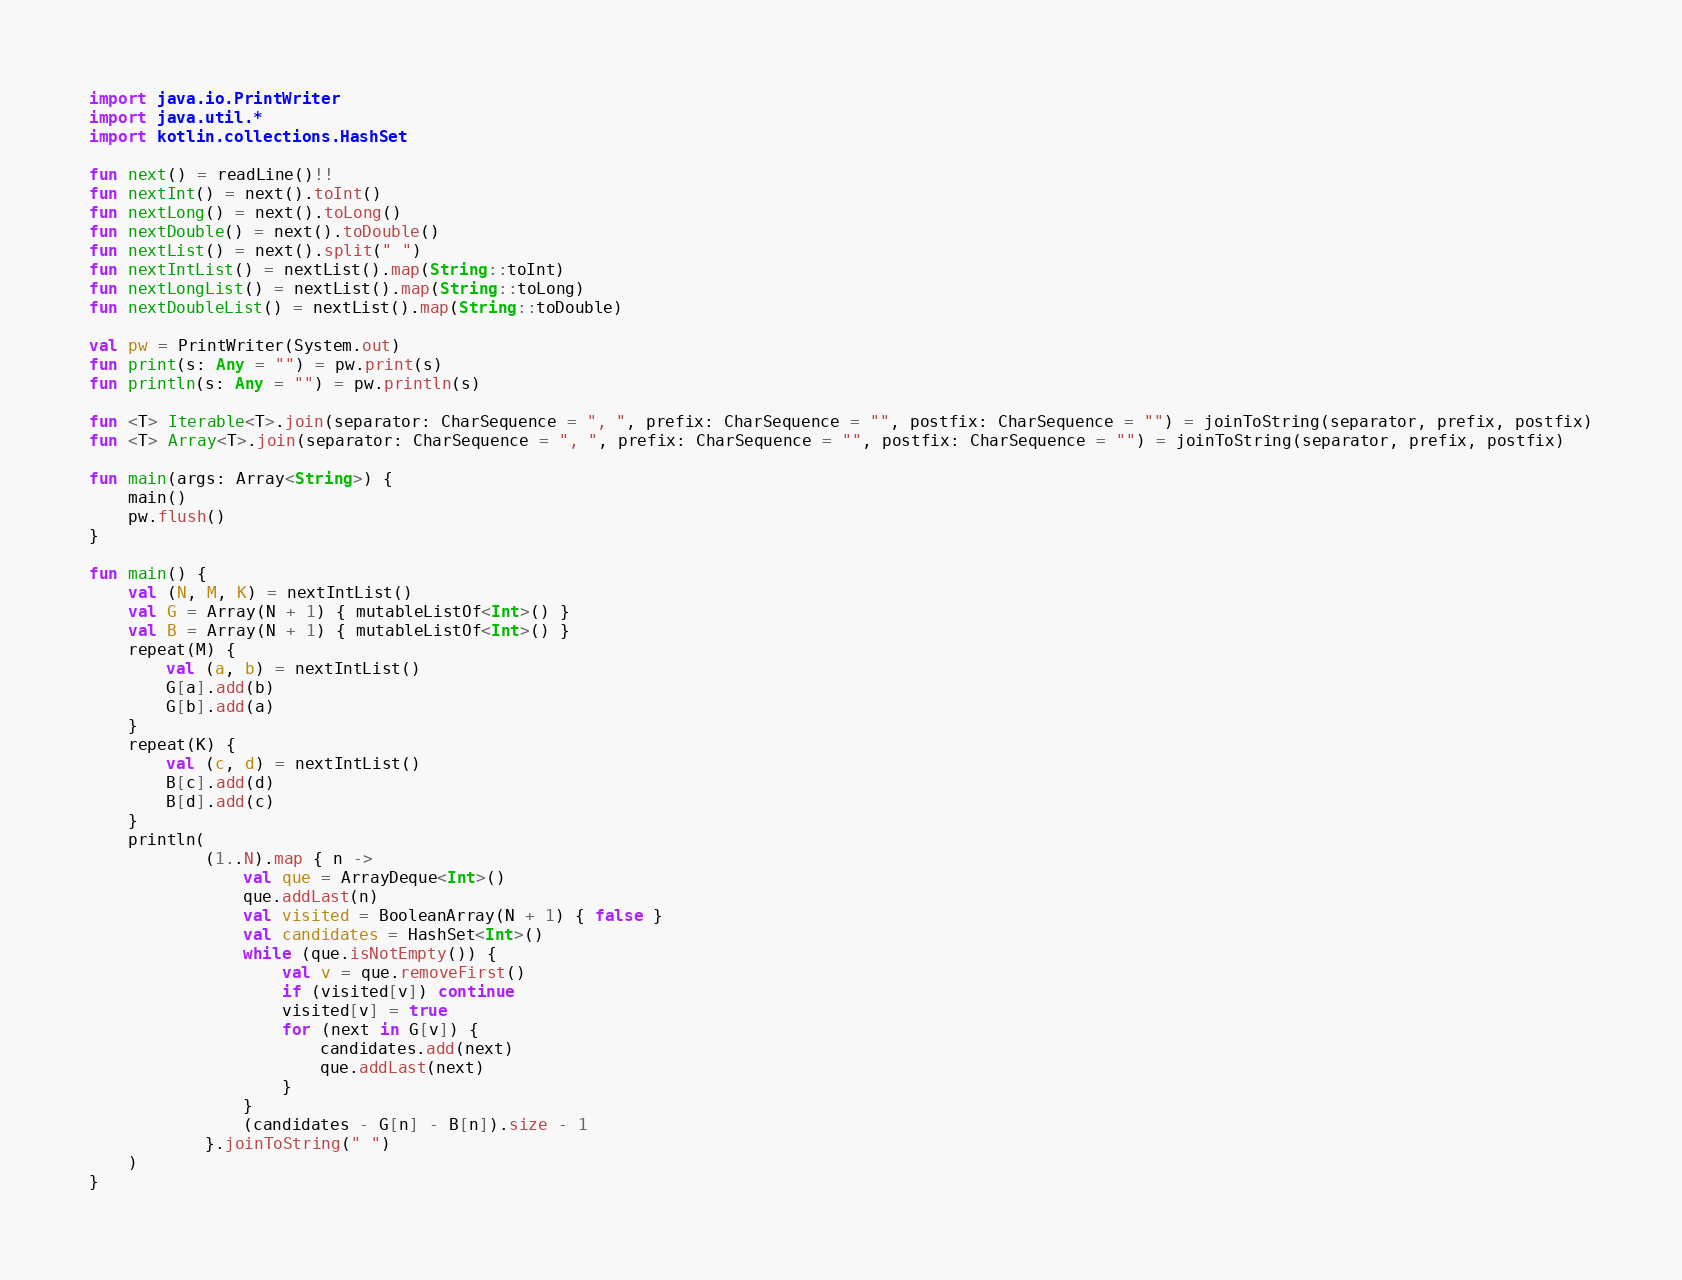Convert code to text. <code><loc_0><loc_0><loc_500><loc_500><_Kotlin_>import java.io.PrintWriter
import java.util.*
import kotlin.collections.HashSet

fun next() = readLine()!!
fun nextInt() = next().toInt()
fun nextLong() = next().toLong()
fun nextDouble() = next().toDouble()
fun nextList() = next().split(" ")
fun nextIntList() = nextList().map(String::toInt)
fun nextLongList() = nextList().map(String::toLong)
fun nextDoubleList() = nextList().map(String::toDouble)

val pw = PrintWriter(System.out)
fun print(s: Any = "") = pw.print(s)
fun println(s: Any = "") = pw.println(s)

fun <T> Iterable<T>.join(separator: CharSequence = ", ", prefix: CharSequence = "", postfix: CharSequence = "") = joinToString(separator, prefix, postfix)
fun <T> Array<T>.join(separator: CharSequence = ", ", prefix: CharSequence = "", postfix: CharSequence = "") = joinToString(separator, prefix, postfix)

fun main(args: Array<String>) {
    main()
    pw.flush()
}

fun main() {
    val (N, M, K) = nextIntList()
    val G = Array(N + 1) { mutableListOf<Int>() }
    val B = Array(N + 1) { mutableListOf<Int>() }
    repeat(M) {
        val (a, b) = nextIntList()
        G[a].add(b)
        G[b].add(a)
    }
    repeat(K) {
        val (c, d) = nextIntList()
        B[c].add(d)
        B[d].add(c)
    }
    println(
            (1..N).map { n ->
                val que = ArrayDeque<Int>()
                que.addLast(n)
                val visited = BooleanArray(N + 1) { false }
                val candidates = HashSet<Int>()
                while (que.isNotEmpty()) {
                    val v = que.removeFirst()
                    if (visited[v]) continue
                    visited[v] = true
                    for (next in G[v]) {
                        candidates.add(next)
                        que.addLast(next)
                    }
                }
                (candidates - G[n] - B[n]).size - 1
            }.joinToString(" ")
    )
}</code> 